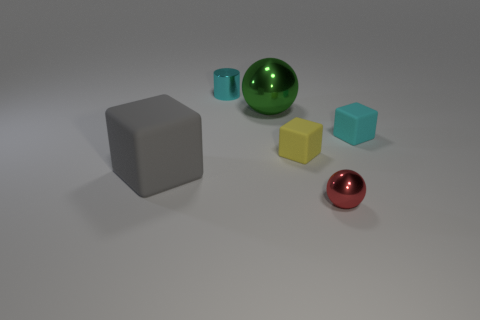There is a rubber cube that is the same color as the small cylinder; what size is it?
Provide a succinct answer. Small. Is there anything else that is the same size as the gray block?
Keep it short and to the point. Yes. Are there fewer small metallic balls in front of the small red metal ball than things?
Provide a short and direct response. Yes. Is the shape of the small cyan metallic thing the same as the small yellow matte thing?
Your answer should be very brief. No. There is another big object that is the same shape as the red shiny thing; what color is it?
Your response must be concise. Green. What number of tiny spheres are the same color as the small cylinder?
Your answer should be compact. 0. How many objects are either cyan cubes to the right of the yellow cube or gray blocks?
Your response must be concise. 2. What size is the cyan thing that is in front of the green shiny object?
Provide a succinct answer. Small. Are there fewer blue things than tiny cylinders?
Your answer should be compact. Yes. Does the small cube that is to the right of the red shiny sphere have the same material as the green sphere behind the small cyan rubber object?
Keep it short and to the point. No. 